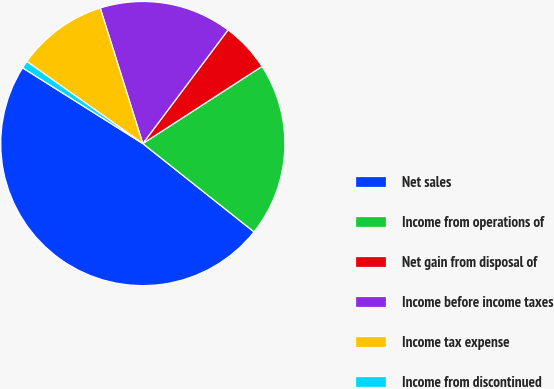<chart> <loc_0><loc_0><loc_500><loc_500><pie_chart><fcel>Net sales<fcel>Income from operations of<fcel>Net gain from disposal of<fcel>Income before income taxes<fcel>Income tax expense<fcel>Income from discontinued<nl><fcel>48.27%<fcel>19.83%<fcel>5.61%<fcel>15.09%<fcel>10.35%<fcel>0.86%<nl></chart> 